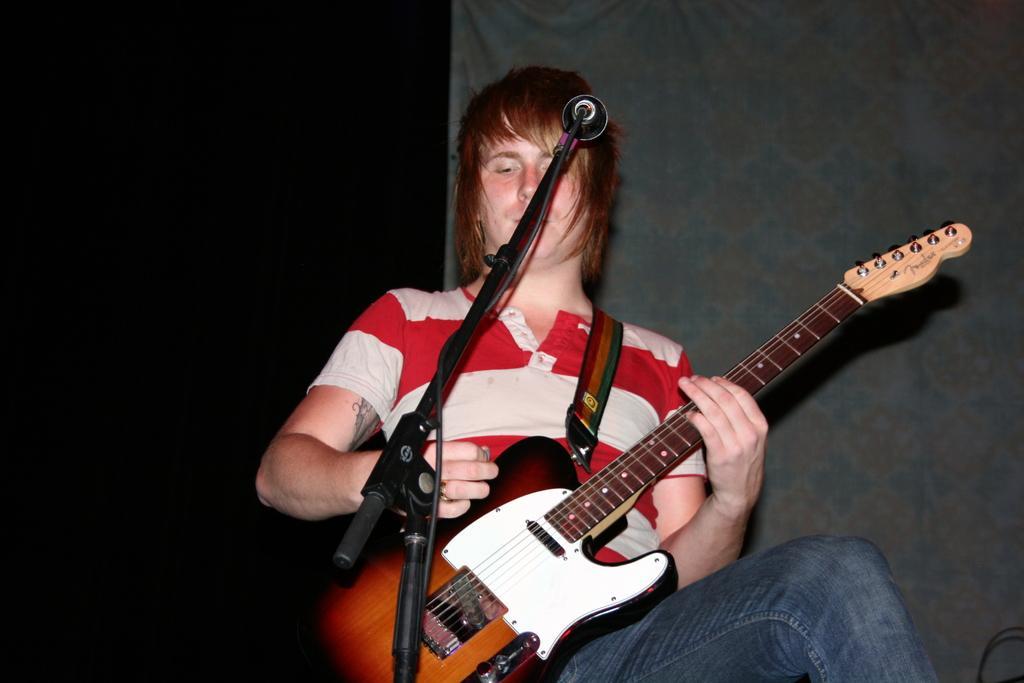How would you summarize this image in a sentence or two? In this image a person is holding a guitar. I think he is playing the guitar. In front of him there is a microphone attached to a stand. He is wearing a red and white t shirt and a jean. His hair color is brown. In the background there is a curtain. 